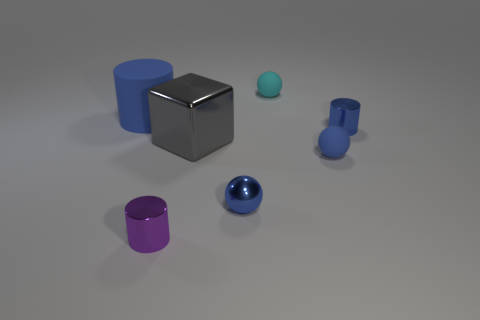What is the shape of the tiny object that is the same material as the tiny cyan sphere?
Your answer should be very brief. Sphere. Do the shiny cylinder left of the cyan ball and the blue metal object that is behind the gray shiny cube have the same size?
Provide a short and direct response. Yes. There is a matte thing on the left side of the gray block; what shape is it?
Your response must be concise. Cylinder. What color is the big metal thing?
Offer a terse response. Gray. There is a blue matte cylinder; is its size the same as the blue metal thing on the right side of the small cyan ball?
Keep it short and to the point. No. How many metallic things are either tiny balls or large green blocks?
Your response must be concise. 1. Is there any other thing that is the same material as the gray cube?
Your answer should be compact. Yes. There is a block; is it the same color as the rubber thing that is in front of the big block?
Your response must be concise. No. The purple object is what shape?
Provide a short and direct response. Cylinder. How big is the blue cylinder right of the small metallic cylinder in front of the blue metal thing in front of the tiny blue metallic cylinder?
Your answer should be compact. Small. 